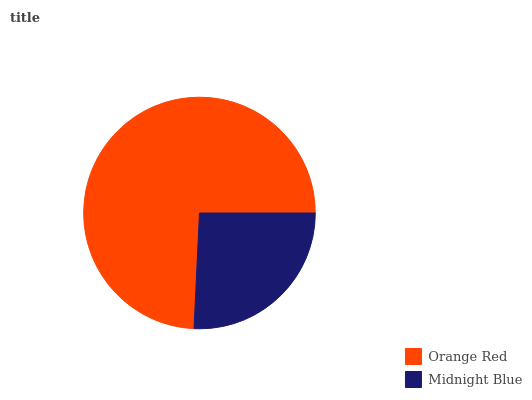Is Midnight Blue the minimum?
Answer yes or no. Yes. Is Orange Red the maximum?
Answer yes or no. Yes. Is Midnight Blue the maximum?
Answer yes or no. No. Is Orange Red greater than Midnight Blue?
Answer yes or no. Yes. Is Midnight Blue less than Orange Red?
Answer yes or no. Yes. Is Midnight Blue greater than Orange Red?
Answer yes or no. No. Is Orange Red less than Midnight Blue?
Answer yes or no. No. Is Orange Red the high median?
Answer yes or no. Yes. Is Midnight Blue the low median?
Answer yes or no. Yes. Is Midnight Blue the high median?
Answer yes or no. No. Is Orange Red the low median?
Answer yes or no. No. 